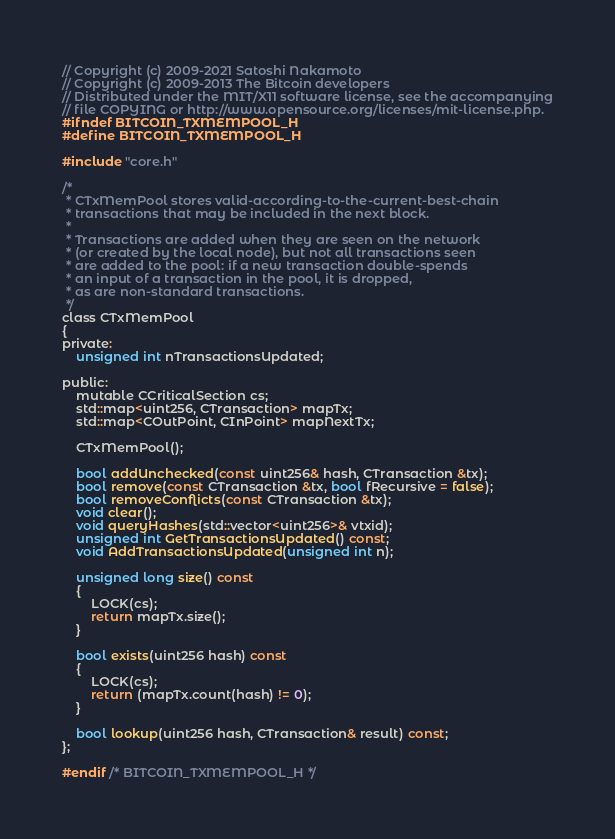<code> <loc_0><loc_0><loc_500><loc_500><_C_>// Copyright (c) 2009-2021 Satoshi Nakamoto
// Copyright (c) 2009-2013 The Bitcoin developers
// Distributed under the MIT/X11 software license, see the accompanying
// file COPYING or http://www.opensource.org/licenses/mit-license.php.
#ifndef BITCOIN_TXMEMPOOL_H
#define BITCOIN_TXMEMPOOL_H

#include "core.h"

/*
 * CTxMemPool stores valid-according-to-the-current-best-chain
 * transactions that may be included in the next block.
 *
 * Transactions are added when they are seen on the network
 * (or created by the local node), but not all transactions seen
 * are added to the pool: if a new transaction double-spends
 * an input of a transaction in the pool, it is dropped,
 * as are non-standard transactions.
 */
class CTxMemPool
{
private:
    unsigned int nTransactionsUpdated;

public:
    mutable CCriticalSection cs;
    std::map<uint256, CTransaction> mapTx;
    std::map<COutPoint, CInPoint> mapNextTx;

    CTxMemPool();

    bool addUnchecked(const uint256& hash, CTransaction &tx);
    bool remove(const CTransaction &tx, bool fRecursive = false);
    bool removeConflicts(const CTransaction &tx);
    void clear();
    void queryHashes(std::vector<uint256>& vtxid);
    unsigned int GetTransactionsUpdated() const;
    void AddTransactionsUpdated(unsigned int n);

    unsigned long size() const
    {
        LOCK(cs);
        return mapTx.size();
    }

    bool exists(uint256 hash) const
    {
        LOCK(cs);
        return (mapTx.count(hash) != 0);
    }

    bool lookup(uint256 hash, CTransaction& result) const;
};

#endif /* BITCOIN_TXMEMPOOL_H */
</code> 